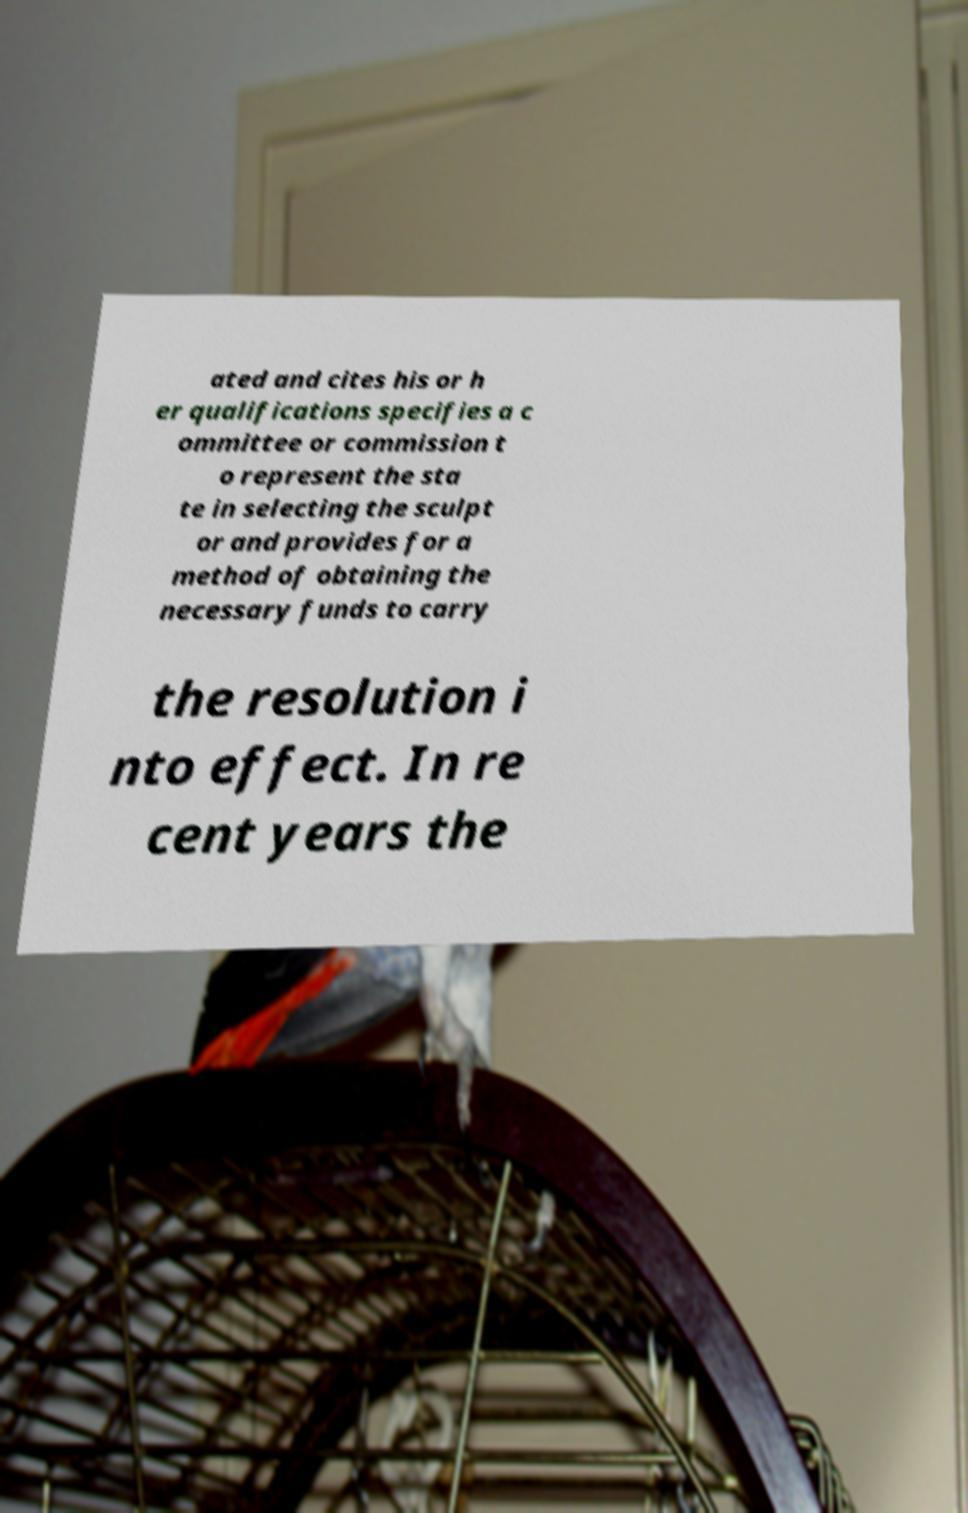Can you accurately transcribe the text from the provided image for me? ated and cites his or h er qualifications specifies a c ommittee or commission t o represent the sta te in selecting the sculpt or and provides for a method of obtaining the necessary funds to carry the resolution i nto effect. In re cent years the 